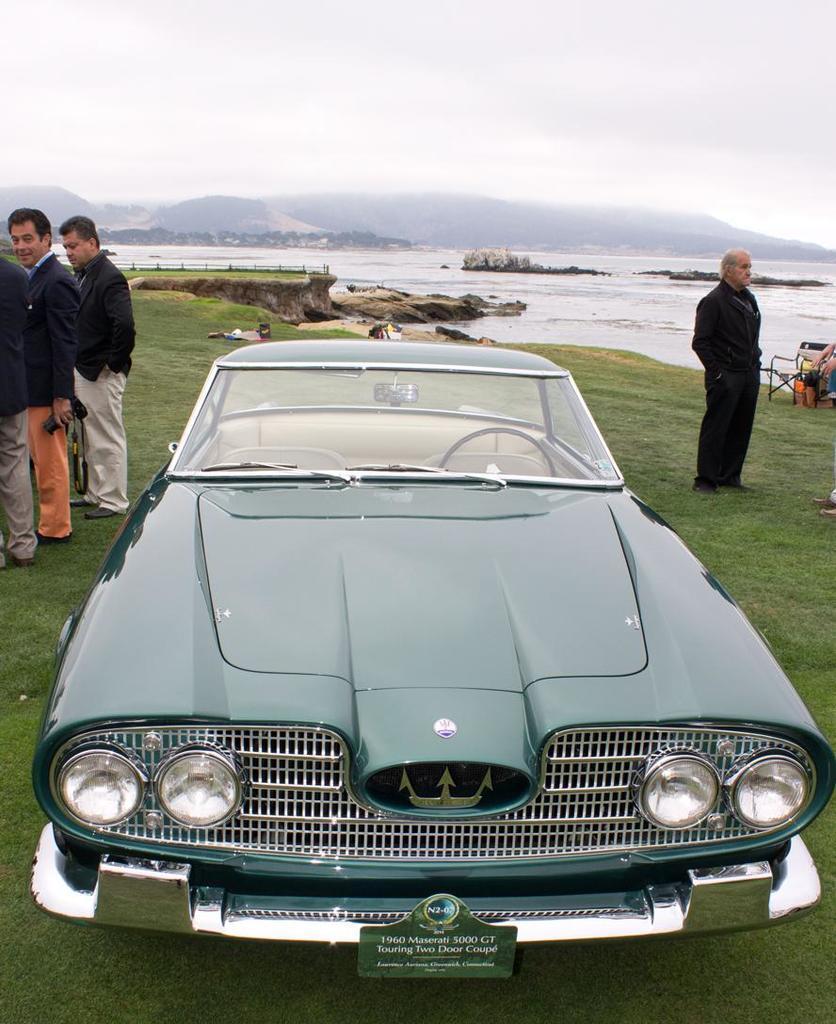In one or two sentences, can you explain what this image depicts? In the picture we can see a vintage car parked on the grass surface which is light green in color and on the other sides we can see some persons and in the background, we can see water and some rocks and we can also see a sky with clouds. 